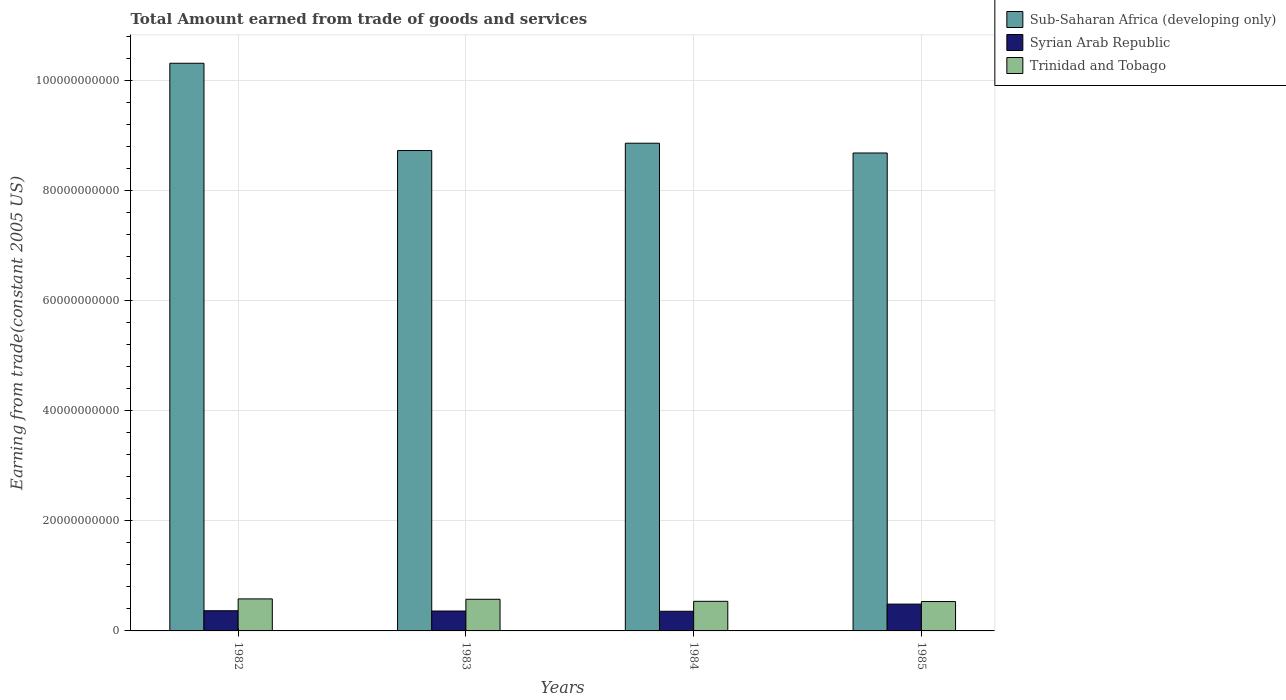How many bars are there on the 2nd tick from the left?
Provide a short and direct response. 3. How many bars are there on the 3rd tick from the right?
Ensure brevity in your answer.  3. What is the label of the 4th group of bars from the left?
Your answer should be compact. 1985. In how many cases, is the number of bars for a given year not equal to the number of legend labels?
Offer a very short reply. 0. What is the total amount earned by trading goods and services in Sub-Saharan Africa (developing only) in 1982?
Ensure brevity in your answer.  1.03e+11. Across all years, what is the maximum total amount earned by trading goods and services in Syrian Arab Republic?
Offer a very short reply. 4.87e+09. Across all years, what is the minimum total amount earned by trading goods and services in Syrian Arab Republic?
Offer a very short reply. 3.57e+09. What is the total total amount earned by trading goods and services in Trinidad and Tobago in the graph?
Your response must be concise. 2.23e+1. What is the difference between the total amount earned by trading goods and services in Sub-Saharan Africa (developing only) in 1982 and that in 1984?
Ensure brevity in your answer.  1.45e+1. What is the difference between the total amount earned by trading goods and services in Sub-Saharan Africa (developing only) in 1985 and the total amount earned by trading goods and services in Trinidad and Tobago in 1984?
Your response must be concise. 8.14e+1. What is the average total amount earned by trading goods and services in Syrian Arab Republic per year?
Your response must be concise. 3.93e+09. In the year 1983, what is the difference between the total amount earned by trading goods and services in Syrian Arab Republic and total amount earned by trading goods and services in Trinidad and Tobago?
Make the answer very short. -2.13e+09. In how many years, is the total amount earned by trading goods and services in Syrian Arab Republic greater than 92000000000 US$?
Your answer should be compact. 0. What is the ratio of the total amount earned by trading goods and services in Sub-Saharan Africa (developing only) in 1982 to that in 1984?
Offer a very short reply. 1.16. Is the total amount earned by trading goods and services in Syrian Arab Republic in 1983 less than that in 1985?
Offer a terse response. Yes. Is the difference between the total amount earned by trading goods and services in Syrian Arab Republic in 1983 and 1985 greater than the difference between the total amount earned by trading goods and services in Trinidad and Tobago in 1983 and 1985?
Keep it short and to the point. No. What is the difference between the highest and the second highest total amount earned by trading goods and services in Trinidad and Tobago?
Provide a succinct answer. 6.95e+07. What is the difference between the highest and the lowest total amount earned by trading goods and services in Syrian Arab Republic?
Your answer should be compact. 1.30e+09. Is the sum of the total amount earned by trading goods and services in Sub-Saharan Africa (developing only) in 1982 and 1984 greater than the maximum total amount earned by trading goods and services in Trinidad and Tobago across all years?
Make the answer very short. Yes. What does the 1st bar from the left in 1983 represents?
Ensure brevity in your answer.  Sub-Saharan Africa (developing only). What does the 1st bar from the right in 1985 represents?
Ensure brevity in your answer.  Trinidad and Tobago. Is it the case that in every year, the sum of the total amount earned by trading goods and services in Syrian Arab Republic and total amount earned by trading goods and services in Trinidad and Tobago is greater than the total amount earned by trading goods and services in Sub-Saharan Africa (developing only)?
Offer a very short reply. No. Are all the bars in the graph horizontal?
Your answer should be compact. No. How many legend labels are there?
Provide a short and direct response. 3. How are the legend labels stacked?
Your response must be concise. Vertical. What is the title of the graph?
Provide a succinct answer. Total Amount earned from trade of goods and services. Does "Cameroon" appear as one of the legend labels in the graph?
Make the answer very short. No. What is the label or title of the Y-axis?
Your answer should be very brief. Earning from trade(constant 2005 US). What is the Earning from trade(constant 2005 US) in Sub-Saharan Africa (developing only) in 1982?
Provide a short and direct response. 1.03e+11. What is the Earning from trade(constant 2005 US) of Syrian Arab Republic in 1982?
Your response must be concise. 3.66e+09. What is the Earning from trade(constant 2005 US) in Trinidad and Tobago in 1982?
Provide a succinct answer. 5.82e+09. What is the Earning from trade(constant 2005 US) of Sub-Saharan Africa (developing only) in 1983?
Your answer should be very brief. 8.72e+1. What is the Earning from trade(constant 2005 US) in Syrian Arab Republic in 1983?
Keep it short and to the point. 3.61e+09. What is the Earning from trade(constant 2005 US) in Trinidad and Tobago in 1983?
Make the answer very short. 5.75e+09. What is the Earning from trade(constant 2005 US) in Sub-Saharan Africa (developing only) in 1984?
Provide a short and direct response. 8.86e+1. What is the Earning from trade(constant 2005 US) of Syrian Arab Republic in 1984?
Your response must be concise. 3.57e+09. What is the Earning from trade(constant 2005 US) in Trinidad and Tobago in 1984?
Offer a very short reply. 5.37e+09. What is the Earning from trade(constant 2005 US) in Sub-Saharan Africa (developing only) in 1985?
Give a very brief answer. 8.68e+1. What is the Earning from trade(constant 2005 US) in Syrian Arab Republic in 1985?
Make the answer very short. 4.87e+09. What is the Earning from trade(constant 2005 US) in Trinidad and Tobago in 1985?
Keep it short and to the point. 5.33e+09. Across all years, what is the maximum Earning from trade(constant 2005 US) of Sub-Saharan Africa (developing only)?
Offer a terse response. 1.03e+11. Across all years, what is the maximum Earning from trade(constant 2005 US) in Syrian Arab Republic?
Ensure brevity in your answer.  4.87e+09. Across all years, what is the maximum Earning from trade(constant 2005 US) of Trinidad and Tobago?
Offer a terse response. 5.82e+09. Across all years, what is the minimum Earning from trade(constant 2005 US) of Sub-Saharan Africa (developing only)?
Keep it short and to the point. 8.68e+1. Across all years, what is the minimum Earning from trade(constant 2005 US) of Syrian Arab Republic?
Provide a succinct answer. 3.57e+09. Across all years, what is the minimum Earning from trade(constant 2005 US) in Trinidad and Tobago?
Offer a terse response. 5.33e+09. What is the total Earning from trade(constant 2005 US) of Sub-Saharan Africa (developing only) in the graph?
Your answer should be very brief. 3.66e+11. What is the total Earning from trade(constant 2005 US) in Syrian Arab Republic in the graph?
Ensure brevity in your answer.  1.57e+1. What is the total Earning from trade(constant 2005 US) of Trinidad and Tobago in the graph?
Ensure brevity in your answer.  2.23e+1. What is the difference between the Earning from trade(constant 2005 US) of Sub-Saharan Africa (developing only) in 1982 and that in 1983?
Give a very brief answer. 1.58e+1. What is the difference between the Earning from trade(constant 2005 US) of Syrian Arab Republic in 1982 and that in 1983?
Give a very brief answer. 4.98e+07. What is the difference between the Earning from trade(constant 2005 US) in Trinidad and Tobago in 1982 and that in 1983?
Your answer should be very brief. 6.95e+07. What is the difference between the Earning from trade(constant 2005 US) of Sub-Saharan Africa (developing only) in 1982 and that in 1984?
Offer a terse response. 1.45e+1. What is the difference between the Earning from trade(constant 2005 US) in Syrian Arab Republic in 1982 and that in 1984?
Give a very brief answer. 9.32e+07. What is the difference between the Earning from trade(constant 2005 US) in Trinidad and Tobago in 1982 and that in 1984?
Make the answer very short. 4.41e+08. What is the difference between the Earning from trade(constant 2005 US) in Sub-Saharan Africa (developing only) in 1982 and that in 1985?
Offer a very short reply. 1.63e+1. What is the difference between the Earning from trade(constant 2005 US) in Syrian Arab Republic in 1982 and that in 1985?
Ensure brevity in your answer.  -1.21e+09. What is the difference between the Earning from trade(constant 2005 US) in Trinidad and Tobago in 1982 and that in 1985?
Offer a terse response. 4.80e+08. What is the difference between the Earning from trade(constant 2005 US) of Sub-Saharan Africa (developing only) in 1983 and that in 1984?
Your answer should be very brief. -1.33e+09. What is the difference between the Earning from trade(constant 2005 US) in Syrian Arab Republic in 1983 and that in 1984?
Ensure brevity in your answer.  4.34e+07. What is the difference between the Earning from trade(constant 2005 US) of Trinidad and Tobago in 1983 and that in 1984?
Your answer should be compact. 3.71e+08. What is the difference between the Earning from trade(constant 2005 US) in Sub-Saharan Africa (developing only) in 1983 and that in 1985?
Your response must be concise. 4.46e+08. What is the difference between the Earning from trade(constant 2005 US) in Syrian Arab Republic in 1983 and that in 1985?
Make the answer very short. -1.26e+09. What is the difference between the Earning from trade(constant 2005 US) of Trinidad and Tobago in 1983 and that in 1985?
Keep it short and to the point. 4.11e+08. What is the difference between the Earning from trade(constant 2005 US) of Sub-Saharan Africa (developing only) in 1984 and that in 1985?
Provide a short and direct response. 1.78e+09. What is the difference between the Earning from trade(constant 2005 US) in Syrian Arab Republic in 1984 and that in 1985?
Your response must be concise. -1.30e+09. What is the difference between the Earning from trade(constant 2005 US) of Trinidad and Tobago in 1984 and that in 1985?
Provide a succinct answer. 3.95e+07. What is the difference between the Earning from trade(constant 2005 US) in Sub-Saharan Africa (developing only) in 1982 and the Earning from trade(constant 2005 US) in Syrian Arab Republic in 1983?
Give a very brief answer. 9.95e+1. What is the difference between the Earning from trade(constant 2005 US) in Sub-Saharan Africa (developing only) in 1982 and the Earning from trade(constant 2005 US) in Trinidad and Tobago in 1983?
Your response must be concise. 9.73e+1. What is the difference between the Earning from trade(constant 2005 US) of Syrian Arab Republic in 1982 and the Earning from trade(constant 2005 US) of Trinidad and Tobago in 1983?
Your response must be concise. -2.08e+09. What is the difference between the Earning from trade(constant 2005 US) in Sub-Saharan Africa (developing only) in 1982 and the Earning from trade(constant 2005 US) in Syrian Arab Republic in 1984?
Offer a terse response. 9.95e+1. What is the difference between the Earning from trade(constant 2005 US) of Sub-Saharan Africa (developing only) in 1982 and the Earning from trade(constant 2005 US) of Trinidad and Tobago in 1984?
Your answer should be compact. 9.77e+1. What is the difference between the Earning from trade(constant 2005 US) in Syrian Arab Republic in 1982 and the Earning from trade(constant 2005 US) in Trinidad and Tobago in 1984?
Your answer should be very brief. -1.71e+09. What is the difference between the Earning from trade(constant 2005 US) of Sub-Saharan Africa (developing only) in 1982 and the Earning from trade(constant 2005 US) of Syrian Arab Republic in 1985?
Give a very brief answer. 9.82e+1. What is the difference between the Earning from trade(constant 2005 US) in Sub-Saharan Africa (developing only) in 1982 and the Earning from trade(constant 2005 US) in Trinidad and Tobago in 1985?
Ensure brevity in your answer.  9.77e+1. What is the difference between the Earning from trade(constant 2005 US) of Syrian Arab Republic in 1982 and the Earning from trade(constant 2005 US) of Trinidad and Tobago in 1985?
Offer a very short reply. -1.67e+09. What is the difference between the Earning from trade(constant 2005 US) in Sub-Saharan Africa (developing only) in 1983 and the Earning from trade(constant 2005 US) in Syrian Arab Republic in 1984?
Offer a terse response. 8.37e+1. What is the difference between the Earning from trade(constant 2005 US) of Sub-Saharan Africa (developing only) in 1983 and the Earning from trade(constant 2005 US) of Trinidad and Tobago in 1984?
Provide a succinct answer. 8.19e+1. What is the difference between the Earning from trade(constant 2005 US) in Syrian Arab Republic in 1983 and the Earning from trade(constant 2005 US) in Trinidad and Tobago in 1984?
Offer a very short reply. -1.76e+09. What is the difference between the Earning from trade(constant 2005 US) of Sub-Saharan Africa (developing only) in 1983 and the Earning from trade(constant 2005 US) of Syrian Arab Republic in 1985?
Your response must be concise. 8.24e+1. What is the difference between the Earning from trade(constant 2005 US) in Sub-Saharan Africa (developing only) in 1983 and the Earning from trade(constant 2005 US) in Trinidad and Tobago in 1985?
Offer a very short reply. 8.19e+1. What is the difference between the Earning from trade(constant 2005 US) of Syrian Arab Republic in 1983 and the Earning from trade(constant 2005 US) of Trinidad and Tobago in 1985?
Give a very brief answer. -1.72e+09. What is the difference between the Earning from trade(constant 2005 US) of Sub-Saharan Africa (developing only) in 1984 and the Earning from trade(constant 2005 US) of Syrian Arab Republic in 1985?
Provide a short and direct response. 8.37e+1. What is the difference between the Earning from trade(constant 2005 US) in Sub-Saharan Africa (developing only) in 1984 and the Earning from trade(constant 2005 US) in Trinidad and Tobago in 1985?
Provide a succinct answer. 8.32e+1. What is the difference between the Earning from trade(constant 2005 US) in Syrian Arab Republic in 1984 and the Earning from trade(constant 2005 US) in Trinidad and Tobago in 1985?
Provide a succinct answer. -1.76e+09. What is the average Earning from trade(constant 2005 US) of Sub-Saharan Africa (developing only) per year?
Offer a very short reply. 9.14e+1. What is the average Earning from trade(constant 2005 US) in Syrian Arab Republic per year?
Provide a succinct answer. 3.93e+09. What is the average Earning from trade(constant 2005 US) in Trinidad and Tobago per year?
Keep it short and to the point. 5.57e+09. In the year 1982, what is the difference between the Earning from trade(constant 2005 US) of Sub-Saharan Africa (developing only) and Earning from trade(constant 2005 US) of Syrian Arab Republic?
Ensure brevity in your answer.  9.94e+1. In the year 1982, what is the difference between the Earning from trade(constant 2005 US) in Sub-Saharan Africa (developing only) and Earning from trade(constant 2005 US) in Trinidad and Tobago?
Your answer should be very brief. 9.73e+1. In the year 1982, what is the difference between the Earning from trade(constant 2005 US) in Syrian Arab Republic and Earning from trade(constant 2005 US) in Trinidad and Tobago?
Ensure brevity in your answer.  -2.15e+09. In the year 1983, what is the difference between the Earning from trade(constant 2005 US) of Sub-Saharan Africa (developing only) and Earning from trade(constant 2005 US) of Syrian Arab Republic?
Ensure brevity in your answer.  8.36e+1. In the year 1983, what is the difference between the Earning from trade(constant 2005 US) of Sub-Saharan Africa (developing only) and Earning from trade(constant 2005 US) of Trinidad and Tobago?
Provide a succinct answer. 8.15e+1. In the year 1983, what is the difference between the Earning from trade(constant 2005 US) of Syrian Arab Republic and Earning from trade(constant 2005 US) of Trinidad and Tobago?
Your response must be concise. -2.13e+09. In the year 1984, what is the difference between the Earning from trade(constant 2005 US) in Sub-Saharan Africa (developing only) and Earning from trade(constant 2005 US) in Syrian Arab Republic?
Your answer should be very brief. 8.50e+1. In the year 1984, what is the difference between the Earning from trade(constant 2005 US) in Sub-Saharan Africa (developing only) and Earning from trade(constant 2005 US) in Trinidad and Tobago?
Make the answer very short. 8.32e+1. In the year 1984, what is the difference between the Earning from trade(constant 2005 US) of Syrian Arab Republic and Earning from trade(constant 2005 US) of Trinidad and Tobago?
Provide a succinct answer. -1.80e+09. In the year 1985, what is the difference between the Earning from trade(constant 2005 US) of Sub-Saharan Africa (developing only) and Earning from trade(constant 2005 US) of Syrian Arab Republic?
Offer a very short reply. 8.19e+1. In the year 1985, what is the difference between the Earning from trade(constant 2005 US) in Sub-Saharan Africa (developing only) and Earning from trade(constant 2005 US) in Trinidad and Tobago?
Keep it short and to the point. 8.14e+1. In the year 1985, what is the difference between the Earning from trade(constant 2005 US) of Syrian Arab Republic and Earning from trade(constant 2005 US) of Trinidad and Tobago?
Provide a succinct answer. -4.65e+08. What is the ratio of the Earning from trade(constant 2005 US) in Sub-Saharan Africa (developing only) in 1982 to that in 1983?
Provide a short and direct response. 1.18. What is the ratio of the Earning from trade(constant 2005 US) of Syrian Arab Republic in 1982 to that in 1983?
Make the answer very short. 1.01. What is the ratio of the Earning from trade(constant 2005 US) of Trinidad and Tobago in 1982 to that in 1983?
Offer a terse response. 1.01. What is the ratio of the Earning from trade(constant 2005 US) in Sub-Saharan Africa (developing only) in 1982 to that in 1984?
Your answer should be compact. 1.16. What is the ratio of the Earning from trade(constant 2005 US) of Syrian Arab Republic in 1982 to that in 1984?
Keep it short and to the point. 1.03. What is the ratio of the Earning from trade(constant 2005 US) in Trinidad and Tobago in 1982 to that in 1984?
Ensure brevity in your answer.  1.08. What is the ratio of the Earning from trade(constant 2005 US) in Sub-Saharan Africa (developing only) in 1982 to that in 1985?
Give a very brief answer. 1.19. What is the ratio of the Earning from trade(constant 2005 US) of Syrian Arab Republic in 1982 to that in 1985?
Ensure brevity in your answer.  0.75. What is the ratio of the Earning from trade(constant 2005 US) of Trinidad and Tobago in 1982 to that in 1985?
Your answer should be very brief. 1.09. What is the ratio of the Earning from trade(constant 2005 US) of Syrian Arab Republic in 1983 to that in 1984?
Your answer should be very brief. 1.01. What is the ratio of the Earning from trade(constant 2005 US) in Trinidad and Tobago in 1983 to that in 1984?
Provide a short and direct response. 1.07. What is the ratio of the Earning from trade(constant 2005 US) of Sub-Saharan Africa (developing only) in 1983 to that in 1985?
Your response must be concise. 1.01. What is the ratio of the Earning from trade(constant 2005 US) in Syrian Arab Republic in 1983 to that in 1985?
Provide a succinct answer. 0.74. What is the ratio of the Earning from trade(constant 2005 US) of Trinidad and Tobago in 1983 to that in 1985?
Offer a terse response. 1.08. What is the ratio of the Earning from trade(constant 2005 US) of Sub-Saharan Africa (developing only) in 1984 to that in 1985?
Give a very brief answer. 1.02. What is the ratio of the Earning from trade(constant 2005 US) in Syrian Arab Republic in 1984 to that in 1985?
Keep it short and to the point. 0.73. What is the ratio of the Earning from trade(constant 2005 US) of Trinidad and Tobago in 1984 to that in 1985?
Keep it short and to the point. 1.01. What is the difference between the highest and the second highest Earning from trade(constant 2005 US) in Sub-Saharan Africa (developing only)?
Give a very brief answer. 1.45e+1. What is the difference between the highest and the second highest Earning from trade(constant 2005 US) in Syrian Arab Republic?
Give a very brief answer. 1.21e+09. What is the difference between the highest and the second highest Earning from trade(constant 2005 US) in Trinidad and Tobago?
Provide a short and direct response. 6.95e+07. What is the difference between the highest and the lowest Earning from trade(constant 2005 US) of Sub-Saharan Africa (developing only)?
Ensure brevity in your answer.  1.63e+1. What is the difference between the highest and the lowest Earning from trade(constant 2005 US) of Syrian Arab Republic?
Your answer should be compact. 1.30e+09. What is the difference between the highest and the lowest Earning from trade(constant 2005 US) of Trinidad and Tobago?
Offer a very short reply. 4.80e+08. 